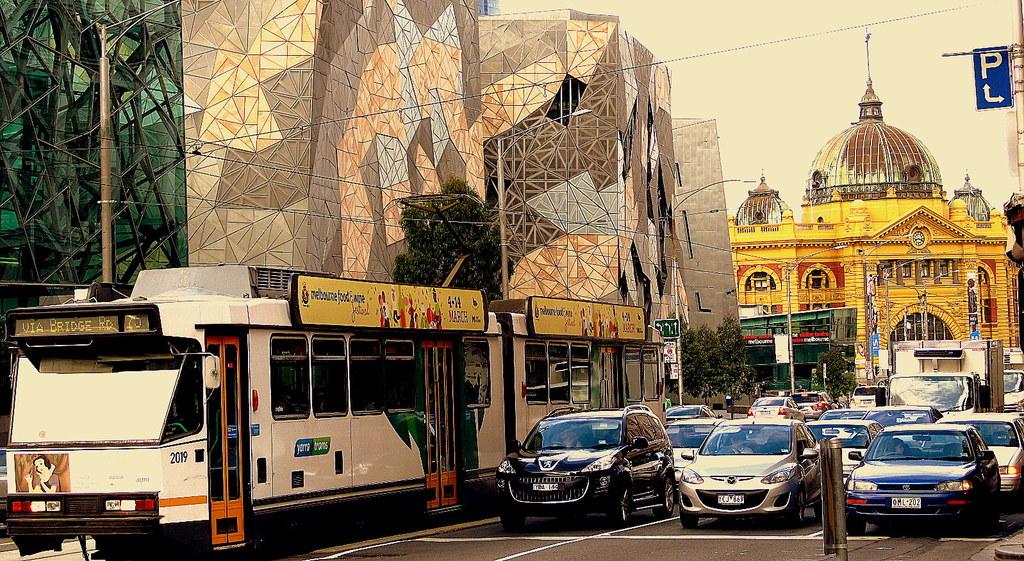Is the text on the blue sign spell p l?
Offer a very short reply. Yes. What route is this bus taking?
Your response must be concise. Unanswerable. 